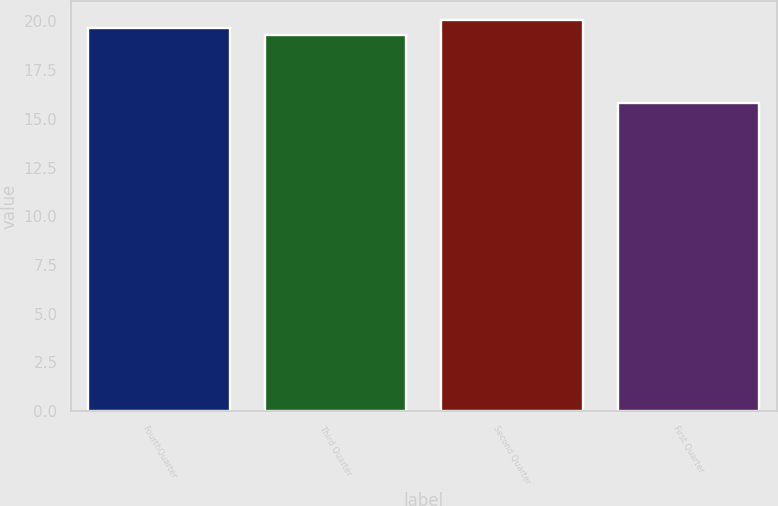<chart> <loc_0><loc_0><loc_500><loc_500><bar_chart><fcel>FourthQuarter<fcel>Third Quarter<fcel>Second Quarter<fcel>First Quarter<nl><fcel>19.67<fcel>19.28<fcel>20.06<fcel>15.81<nl></chart> 